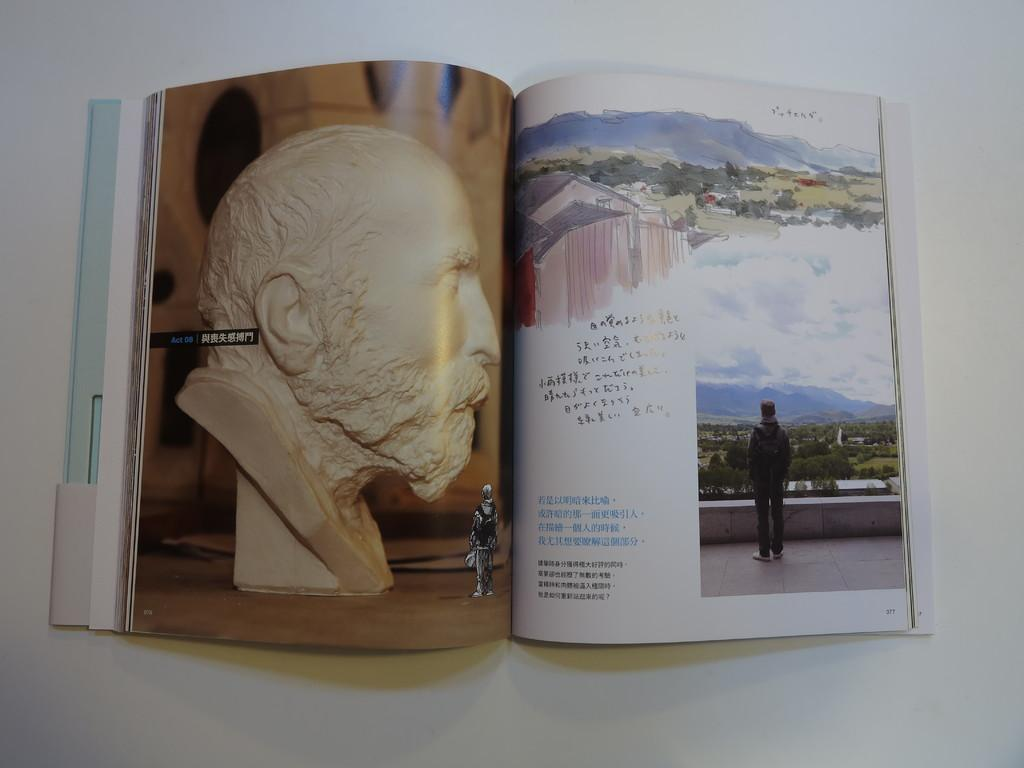<image>
Render a clear and concise summary of the photo. A glossy paged book is opened to page 077. 